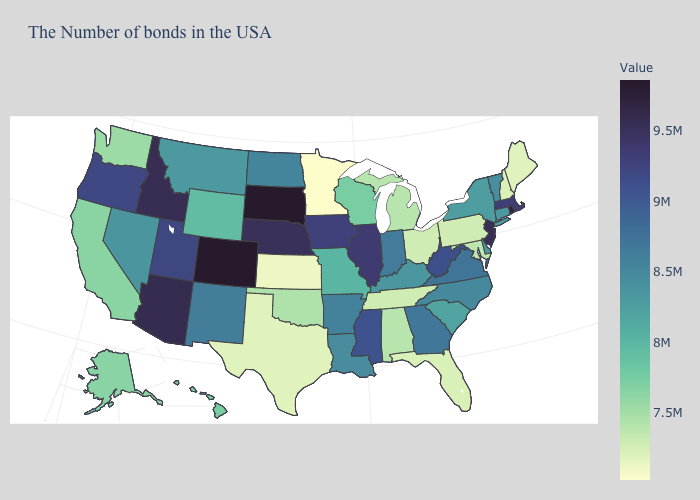Does the map have missing data?
Short answer required. No. Is the legend a continuous bar?
Be succinct. Yes. 